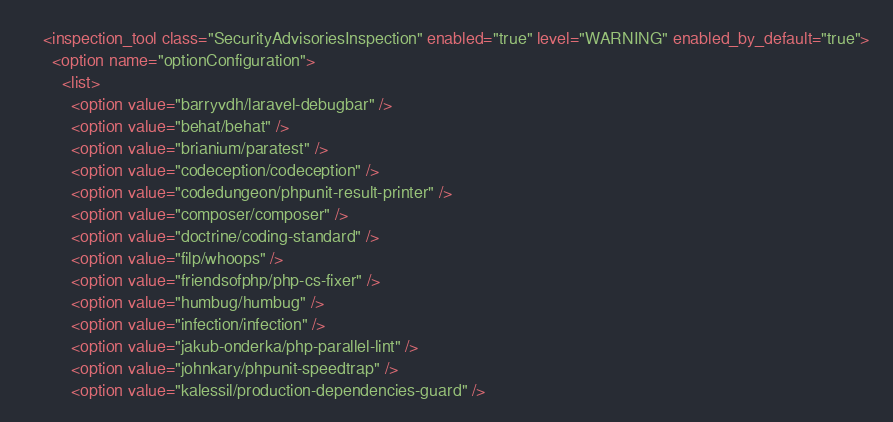<code> <loc_0><loc_0><loc_500><loc_500><_XML_>    <inspection_tool class="SecurityAdvisoriesInspection" enabled="true" level="WARNING" enabled_by_default="true">
      <option name="optionConfiguration">
        <list>
          <option value="barryvdh/laravel-debugbar" />
          <option value="behat/behat" />
          <option value="brianium/paratest" />
          <option value="codeception/codeception" />
          <option value="codedungeon/phpunit-result-printer" />
          <option value="composer/composer" />
          <option value="doctrine/coding-standard" />
          <option value="filp/whoops" />
          <option value="friendsofphp/php-cs-fixer" />
          <option value="humbug/humbug" />
          <option value="infection/infection" />
          <option value="jakub-onderka/php-parallel-lint" />
          <option value="johnkary/phpunit-speedtrap" />
          <option value="kalessil/production-dependencies-guard" /></code> 